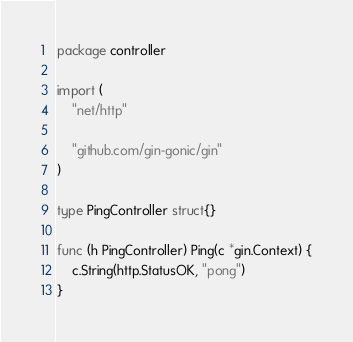<code> <loc_0><loc_0><loc_500><loc_500><_Go_>package controller

import (
	"net/http"

	"github.com/gin-gonic/gin"
)

type PingController struct{}

func (h PingController) Ping(c *gin.Context) {
	c.String(http.StatusOK, "pong")
}
</code> 